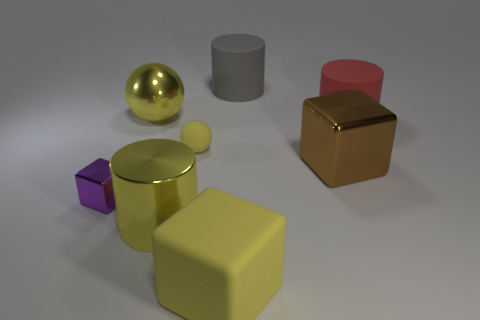Subtract all matte cylinders. How many cylinders are left? 1 Subtract all gray cylinders. How many cylinders are left? 2 Subtract all blocks. How many objects are left? 5 Add 1 big things. How many objects exist? 9 Subtract 1 blocks. How many blocks are left? 2 Subtract all blue cubes. Subtract all blue balls. How many cubes are left? 3 Subtract all brown cylinders. How many purple blocks are left? 1 Subtract all small brown balls. Subtract all yellow matte cubes. How many objects are left? 7 Add 5 tiny purple shiny cubes. How many tiny purple shiny cubes are left? 6 Add 8 large yellow matte objects. How many large yellow matte objects exist? 9 